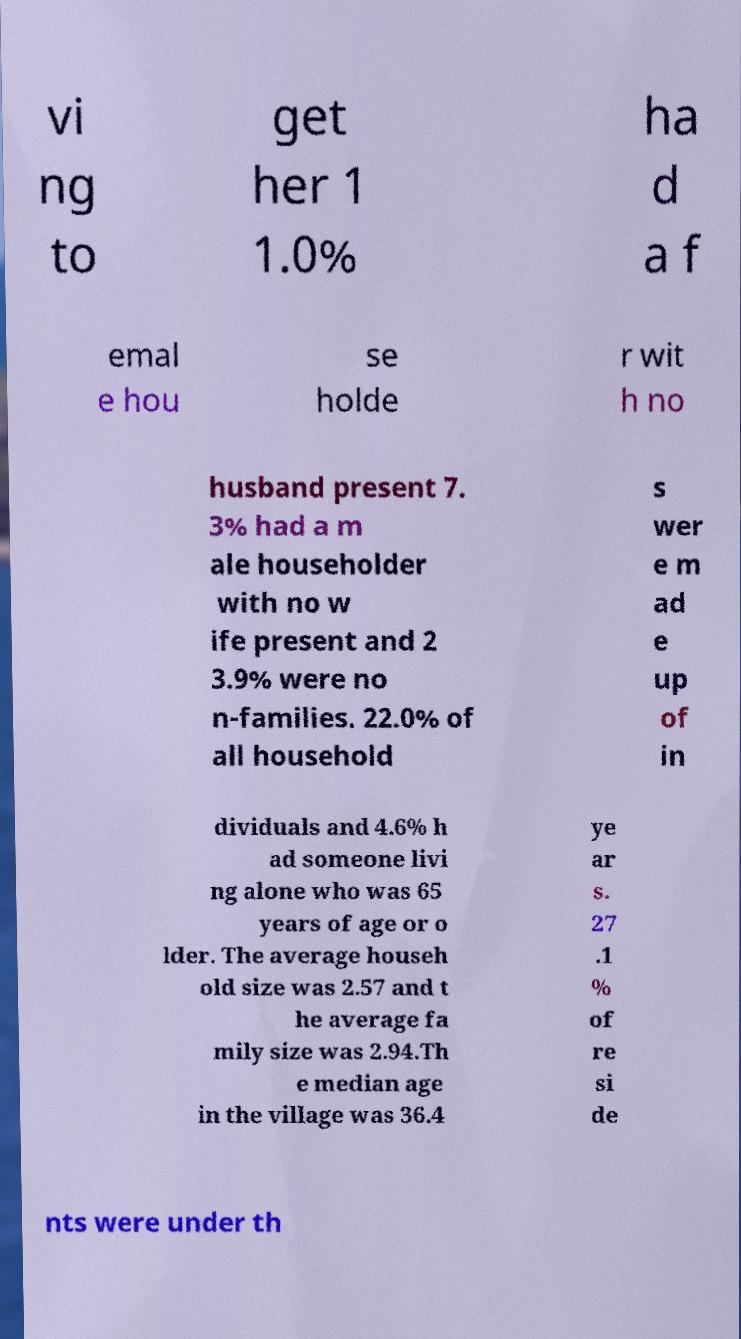Can you read and provide the text displayed in the image?This photo seems to have some interesting text. Can you extract and type it out for me? vi ng to get her 1 1.0% ha d a f emal e hou se holde r wit h no husband present 7. 3% had a m ale householder with no w ife present and 2 3.9% were no n-families. 22.0% of all household s wer e m ad e up of in dividuals and 4.6% h ad someone livi ng alone who was 65 years of age or o lder. The average househ old size was 2.57 and t he average fa mily size was 2.94.Th e median age in the village was 36.4 ye ar s. 27 .1 % of re si de nts were under th 